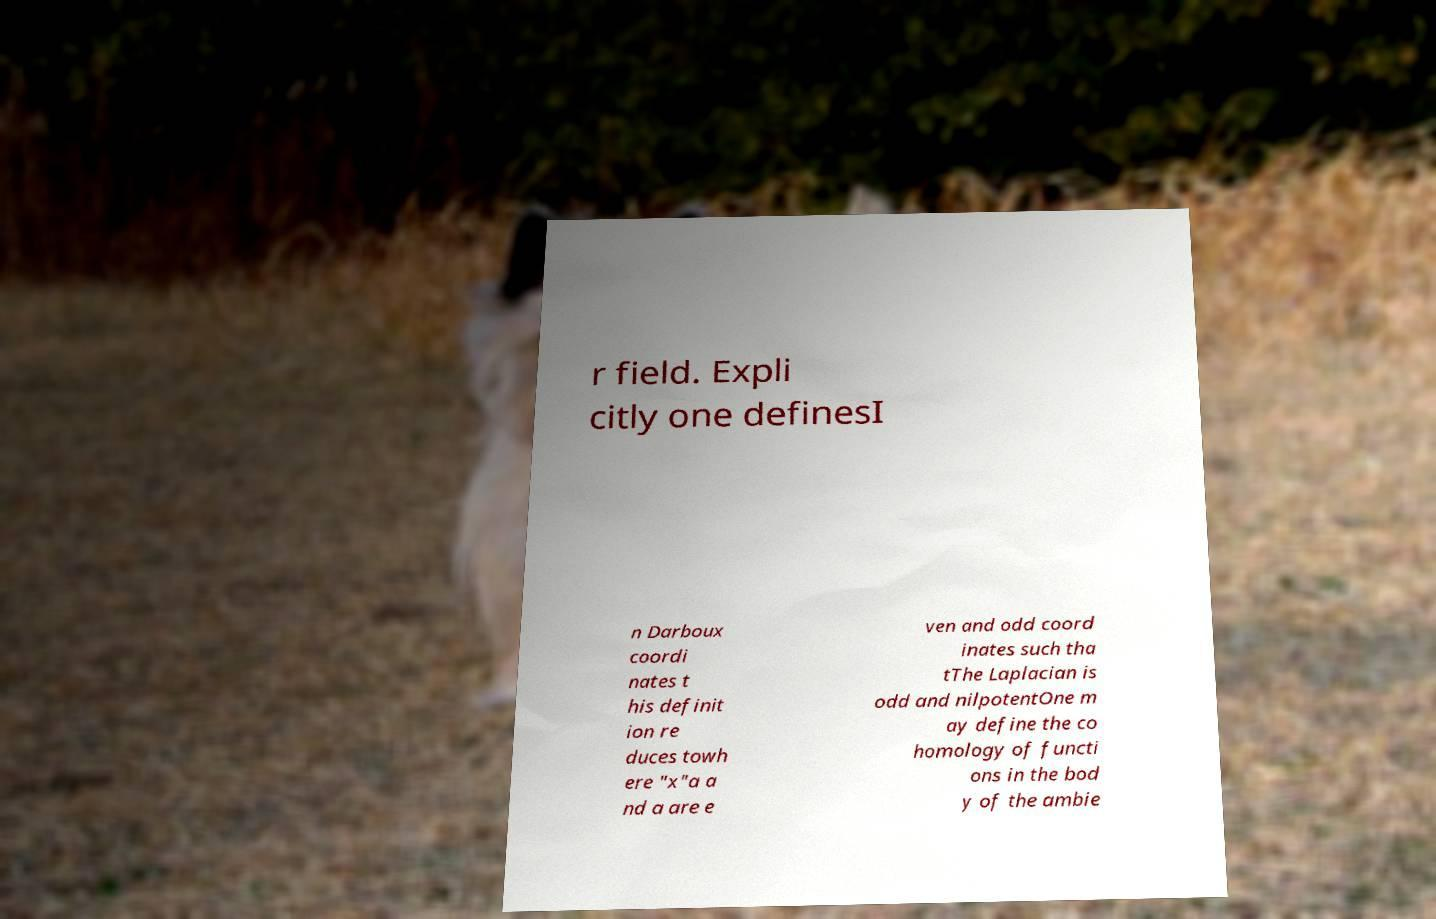For documentation purposes, I need the text within this image transcribed. Could you provide that? r field. Expli citly one definesI n Darboux coordi nates t his definit ion re duces towh ere "x"a a nd a are e ven and odd coord inates such tha tThe Laplacian is odd and nilpotentOne m ay define the co homology of functi ons in the bod y of the ambie 